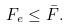<formula> <loc_0><loc_0><loc_500><loc_500>F _ { e } \leq \bar { F } .</formula> 